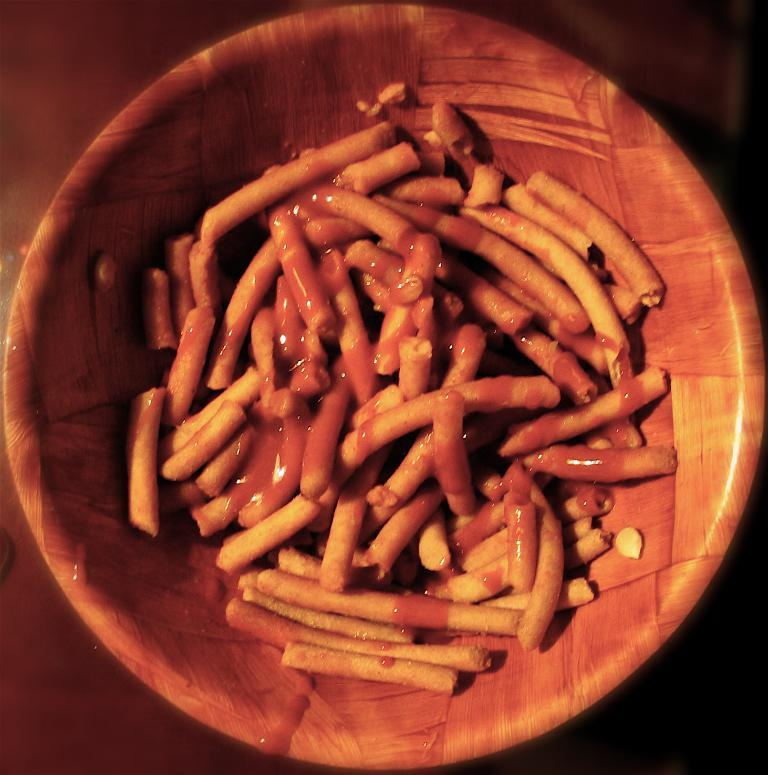What is in the bowl that is visible in the image? The bowl contains food items. What type of surface is the bowl placed on? The bowl is placed on a wooden surface. How many threads are used to tie the knot in the image? There is no knot or thread present in the image. 